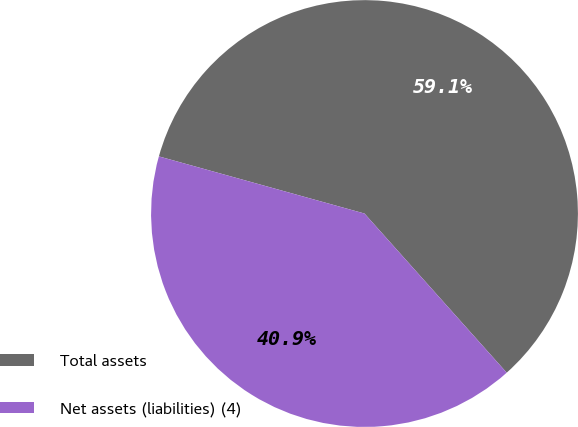Convert chart. <chart><loc_0><loc_0><loc_500><loc_500><pie_chart><fcel>Total assets<fcel>Net assets (liabilities) (4)<nl><fcel>59.08%<fcel>40.92%<nl></chart> 